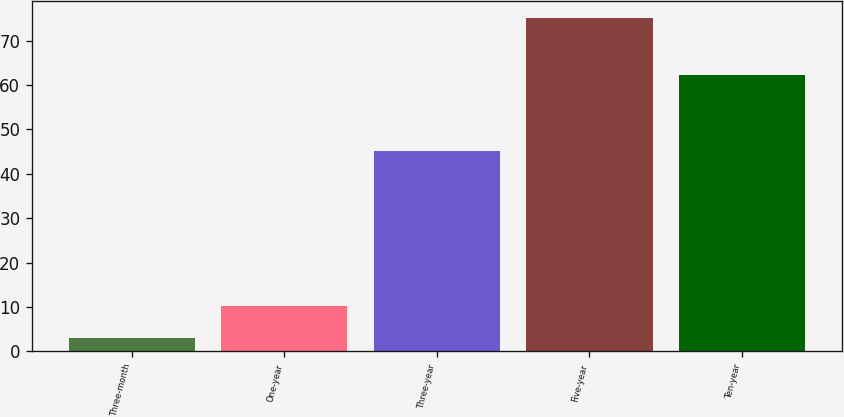Convert chart. <chart><loc_0><loc_0><loc_500><loc_500><bar_chart><fcel>Three-month<fcel>One-year<fcel>Three-year<fcel>Five-year<fcel>Ten-year<nl><fcel>3<fcel>10.22<fcel>45.2<fcel>75.2<fcel>62.3<nl></chart> 